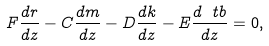Convert formula to latex. <formula><loc_0><loc_0><loc_500><loc_500>F \frac { d r } { d z } - C \frac { d m } { d z } - D \frac { d k } { d z } - E \frac { d \ t b } { d z } = 0 ,</formula> 